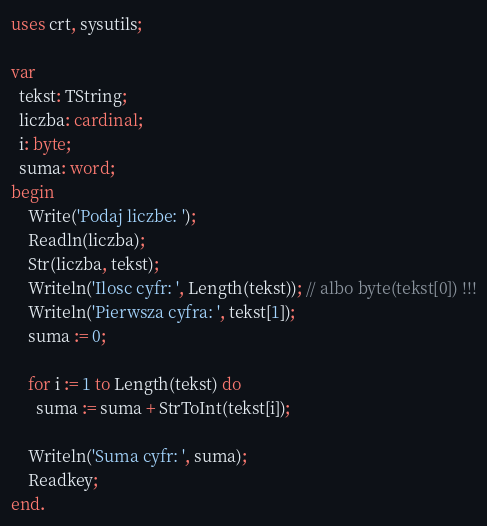<code> <loc_0><loc_0><loc_500><loc_500><_Pascal_>
uses crt, sysutils;

var
  tekst: TString;
  liczba: cardinal;
  i: byte;
  suma: word;
begin
    Write('Podaj liczbe: ');
    Readln(liczba);
    Str(liczba, tekst);
    Writeln('Ilosc cyfr: ', Length(tekst)); // albo byte(tekst[0]) !!!
    Writeln('Pierwsza cyfra: ', tekst[1]);
    suma := 0;

    for i := 1 to Length(tekst) do
      suma := suma + StrToInt(tekst[i]);

    Writeln('Suma cyfr: ', suma);
    Readkey;
end.
</code> 